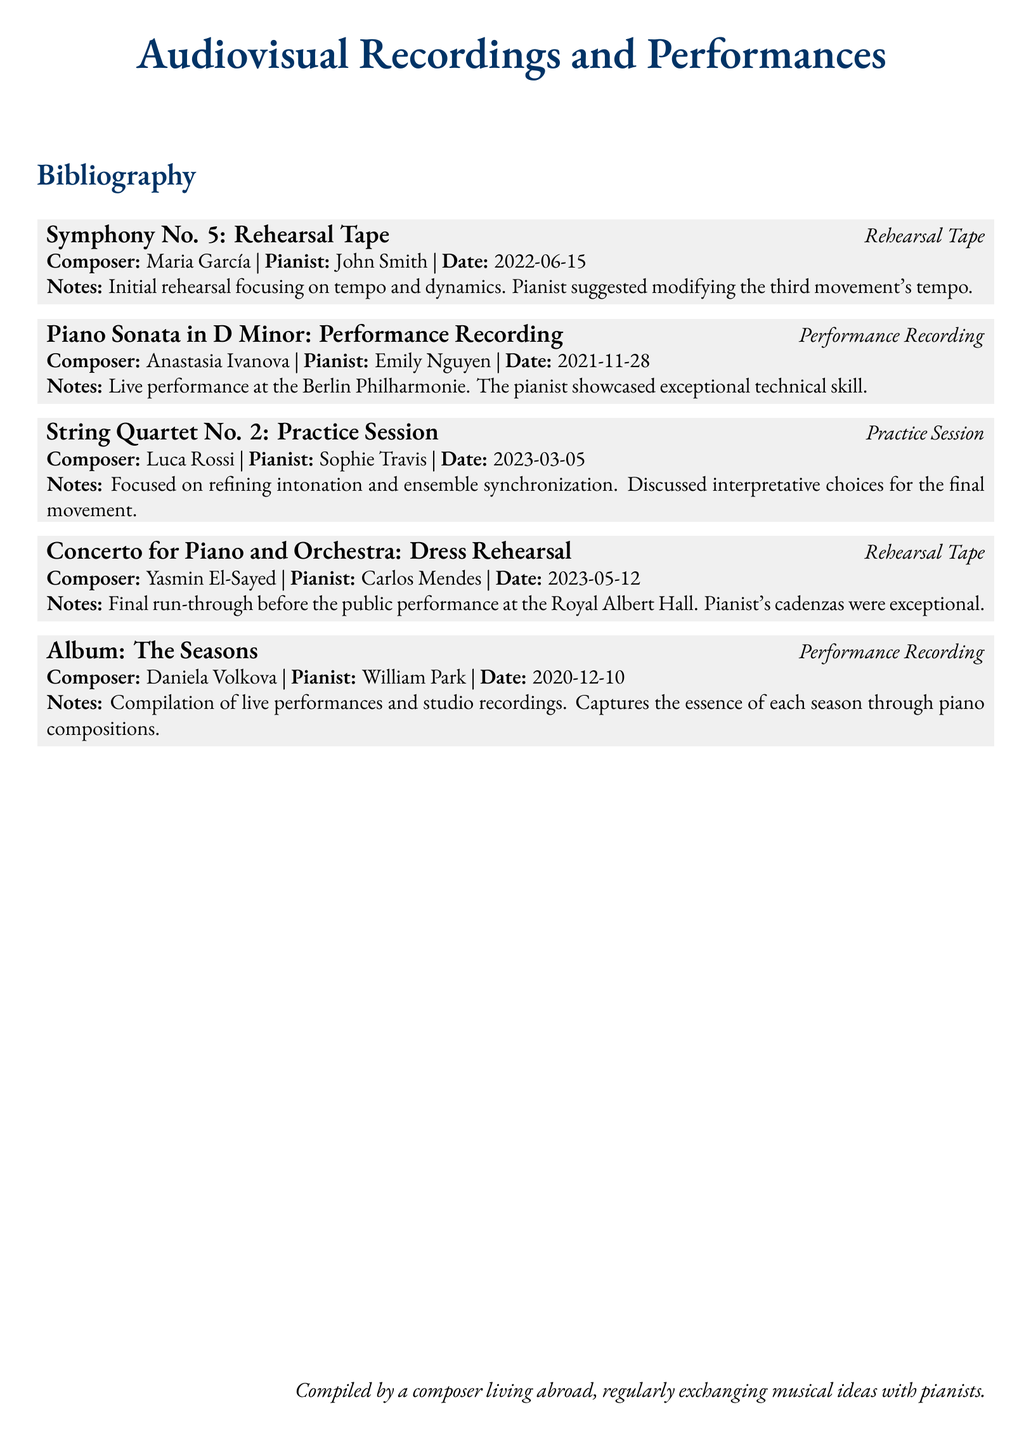What is the title of the rehearsal tape? The title provided in the document is "Symphony No. 5: Rehearsal Tape."
Answer: Symphony No. 5: Rehearsal Tape Who is the composer of the "Concerto for Piano and Orchestra"? The document lists Yasmin El-Sayed as the composer of the concerto.
Answer: Yasmin El-Sayed What date was the "Piano Sonata in D Minor: Performance Recording" performed? The performance took place on November 28, 2021.
Answer: 2021-11-28 How many entries are there in the bibliography? There are five different entries listed in the document, each corresponding to different audiovisual materials.
Answer: 5 What feedback did the pianist provide on the "Symphony No. 5" rehearsal? The pianist suggested modifying the third movement's tempo during the rehearsal.
Answer: Modifying the third movement's tempo Which performance was described as showcasing exceptional technical skill? The description refers to the live performance of the "Piano Sonata in D Minor."
Answer: Piano Sonata in D Minor What was the focus of the practice session for "String Quartet No. 2"? The practice session focused on refining intonation and ensemble synchronization.
Answer: Refining intonation and ensemble synchronization What type of recording is "Album: The Seasons"? The document characterizes this entry as a performance recording.
Answer: Performance Recording What significant event occurred on 2023-05-12? This date corresponds to the dress rehearsal for the "Concerto for Piano and Orchestra."
Answer: Dress rehearsal for Concerto for Piano and Orchestra 